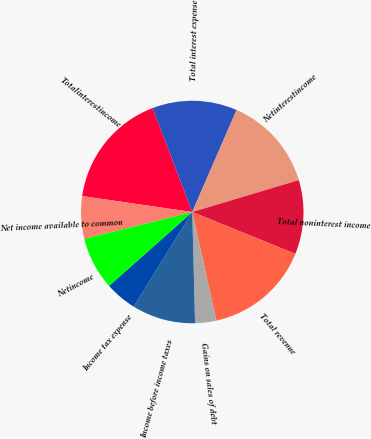Convert chart. <chart><loc_0><loc_0><loc_500><loc_500><pie_chart><fcel>Totalinterestincome<fcel>Total interest expense<fcel>Netinterestincome<fcel>Total noninterest income<fcel>Total revenue<fcel>Gains on sales of debt<fcel>Income before income taxes<fcel>Income tax expense<fcel>Netincome<fcel>Net income available to common<nl><fcel>16.92%<fcel>12.31%<fcel>13.85%<fcel>10.77%<fcel>15.38%<fcel>3.08%<fcel>9.23%<fcel>4.62%<fcel>7.69%<fcel>6.15%<nl></chart> 